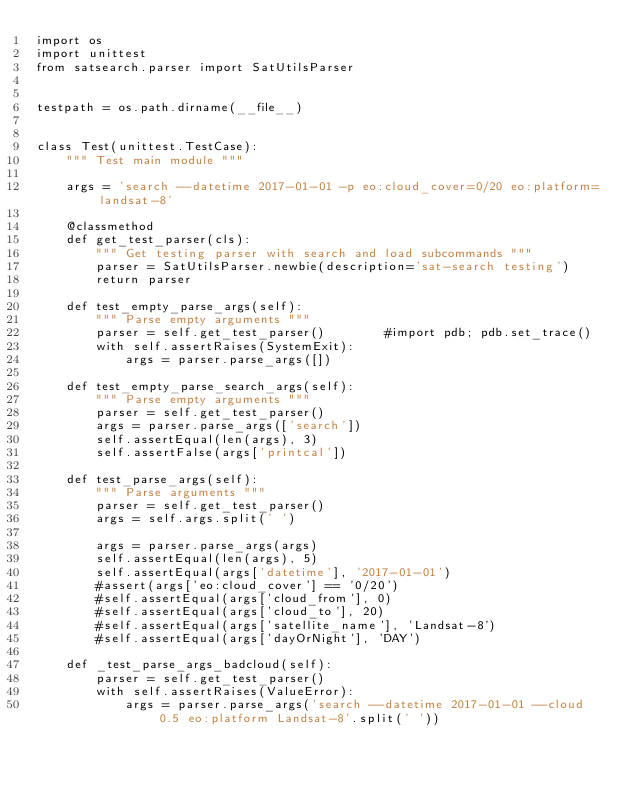<code> <loc_0><loc_0><loc_500><loc_500><_Python_>import os
import unittest
from satsearch.parser import SatUtilsParser


testpath = os.path.dirname(__file__)


class Test(unittest.TestCase):
    """ Test main module """

    args = 'search --datetime 2017-01-01 -p eo:cloud_cover=0/20 eo:platform=landsat-8'

    @classmethod
    def get_test_parser(cls):
        """ Get testing parser with search and load subcommands """
        parser = SatUtilsParser.newbie(description='sat-search testing')
        return parser

    def test_empty_parse_args(self):
        """ Parse empty arguments """
        parser = self.get_test_parser()        #import pdb; pdb.set_trace()
        with self.assertRaises(SystemExit):
            args = parser.parse_args([])   

    def test_empty_parse_search_args(self):
        """ Parse empty arguments """
        parser = self.get_test_parser()
        args = parser.parse_args(['search'])
        self.assertEqual(len(args), 3)
        self.assertFalse(args['printcal'])

    def test_parse_args(self):
        """ Parse arguments """
        parser = self.get_test_parser()
        args = self.args.split(' ')
        
        args = parser.parse_args(args)
        self.assertEqual(len(args), 5)
        self.assertEqual(args['datetime'], '2017-01-01')
        #assert(args['eo:cloud_cover'] == '0/20')
        #self.assertEqual(args['cloud_from'], 0)
        #self.assertEqual(args['cloud_to'], 20)
        #self.assertEqual(args['satellite_name'], 'Landsat-8')
        #self.assertEqual(args['dayOrNight'], 'DAY')

    def _test_parse_args_badcloud(self):
        parser = self.get_test_parser()
        with self.assertRaises(ValueError):
            args = parser.parse_args('search --datetime 2017-01-01 --cloud 0.5 eo:platform Landsat-8'.split(' '))
</code> 